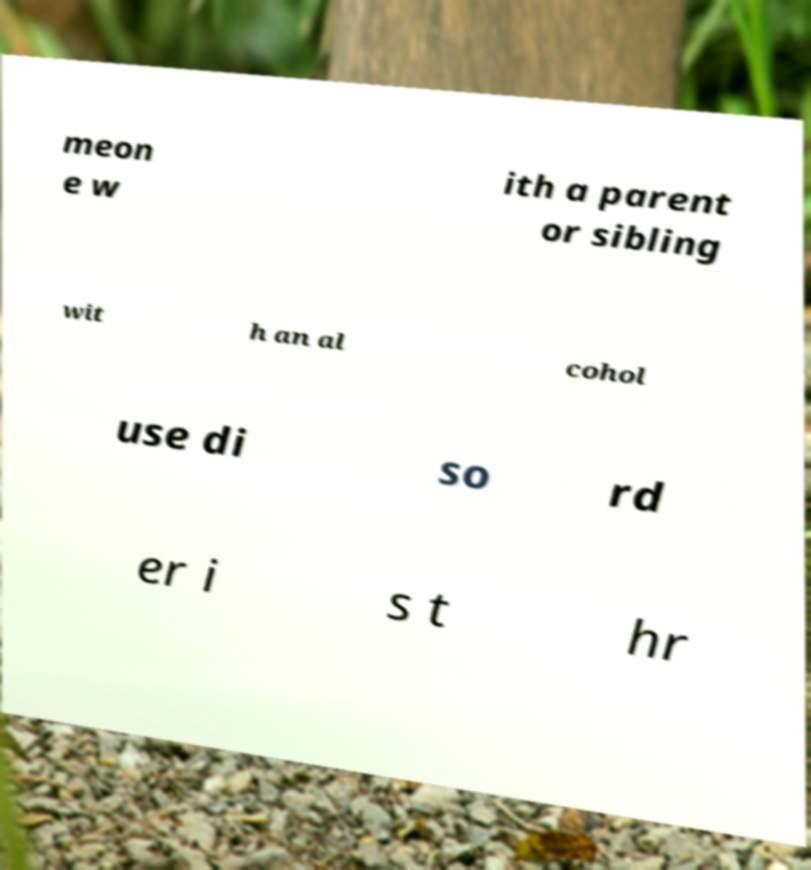Can you accurately transcribe the text from the provided image for me? meon e w ith a parent or sibling wit h an al cohol use di so rd er i s t hr 